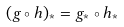<formula> <loc_0><loc_0><loc_500><loc_500>( g \circ h ) _ { * } = g _ { * } \circ h _ { * }</formula> 